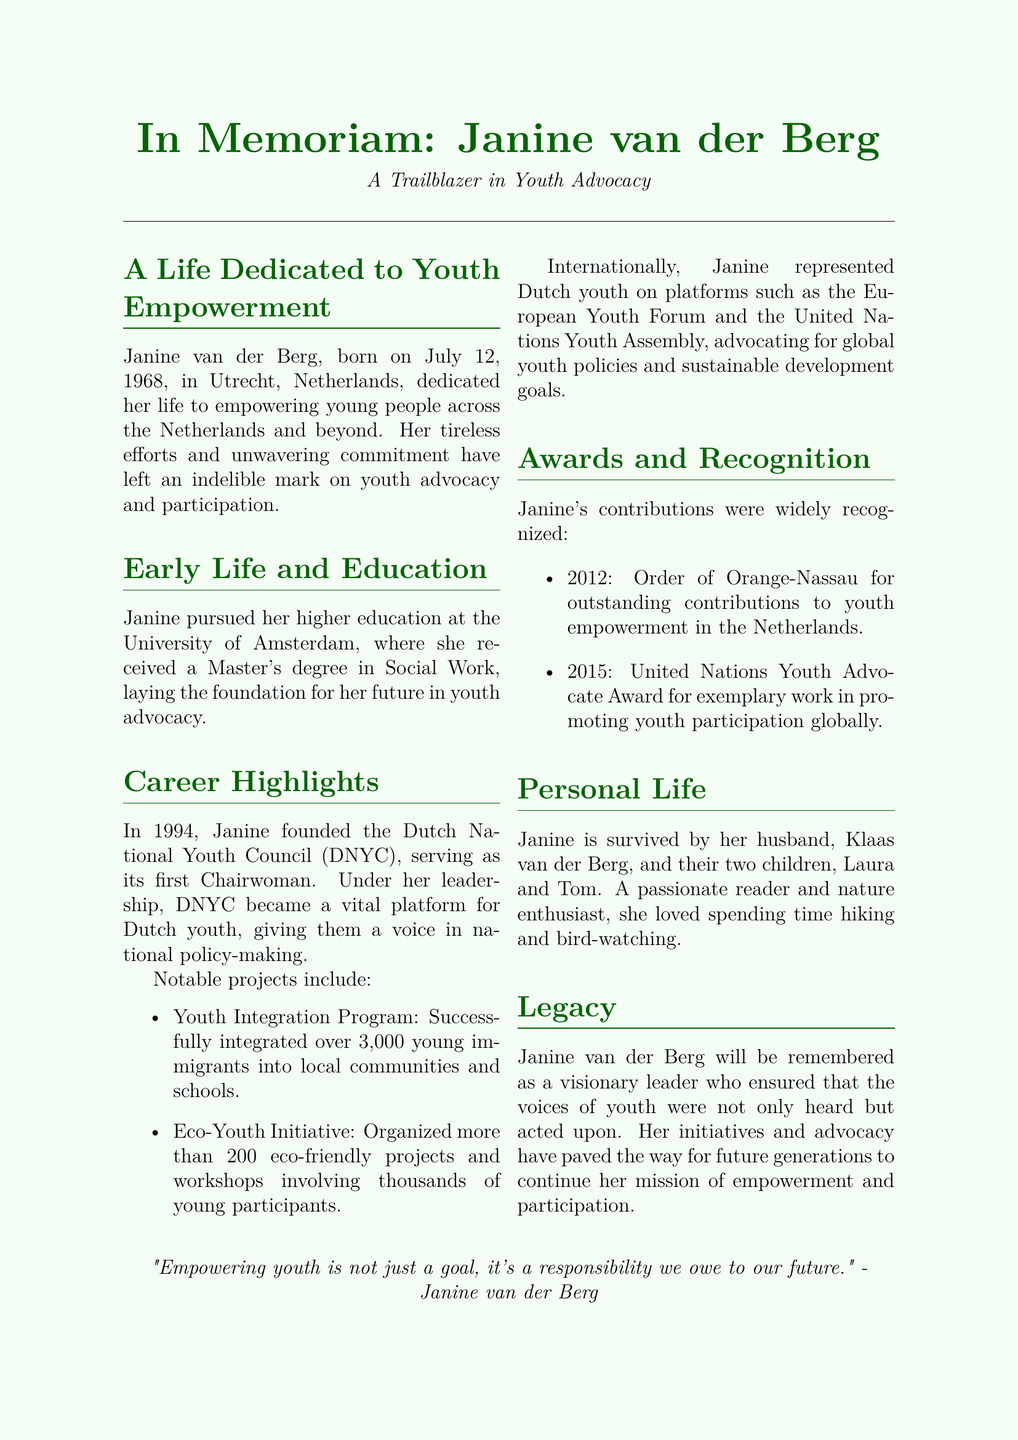What is the date of birth of Janine van der Berg? Janine van der Berg was born on July 12, 1968, as stated in the early life section.
Answer: July 12, 1968 What organization did Janine van der Berg found? She founded the Dutch National Youth Council (DNYC) in 1994, as noted in her career highlights.
Answer: Dutch National Youth Council (DNYC) How many young immigrants were successfully integrated into local communities by the Youth Integration Program? The program successfully integrated over 3,000 young immigrants, which is detailed under notable projects.
Answer: 3,000 What award did Janine receive in 2012? She received the Order of Orange-Nassau for outstanding contributions to youth empowerment in the Netherlands, as mentioned in the awards section.
Answer: Order of Orange-Nassau Who is Janine van der Berg survived by? The document states that she is survived by her husband, Klaas van der Berg, and their two children, Laura and Tom.
Answer: Klaas van der Berg, Laura, and Tom What was Janine's educational background? She received a Master's degree in Social Work from the University of Amsterdam, as noted in the early life and education section.
Answer: Master's degree in Social Work What quote is attributed to Janine van der Berg? The document includes a quotation by Janine that relates to the empowerment of youth and responsibility for the future.
Answer: "Empowering youth is not just a goal, it's a responsibility we owe to our future." Which international platforms did Janine represent Dutch youth? Janine represented Dutch youth on platforms such as the European Youth Forum and the United Nations Youth Assembly, stated in her career highlights.
Answer: European Youth Forum and United Nations Youth Assembly 